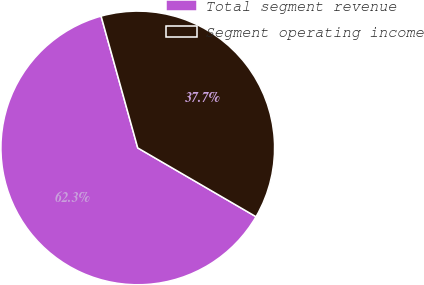Convert chart. <chart><loc_0><loc_0><loc_500><loc_500><pie_chart><fcel>Total segment revenue<fcel>Segment operating income<nl><fcel>62.3%<fcel>37.7%<nl></chart> 